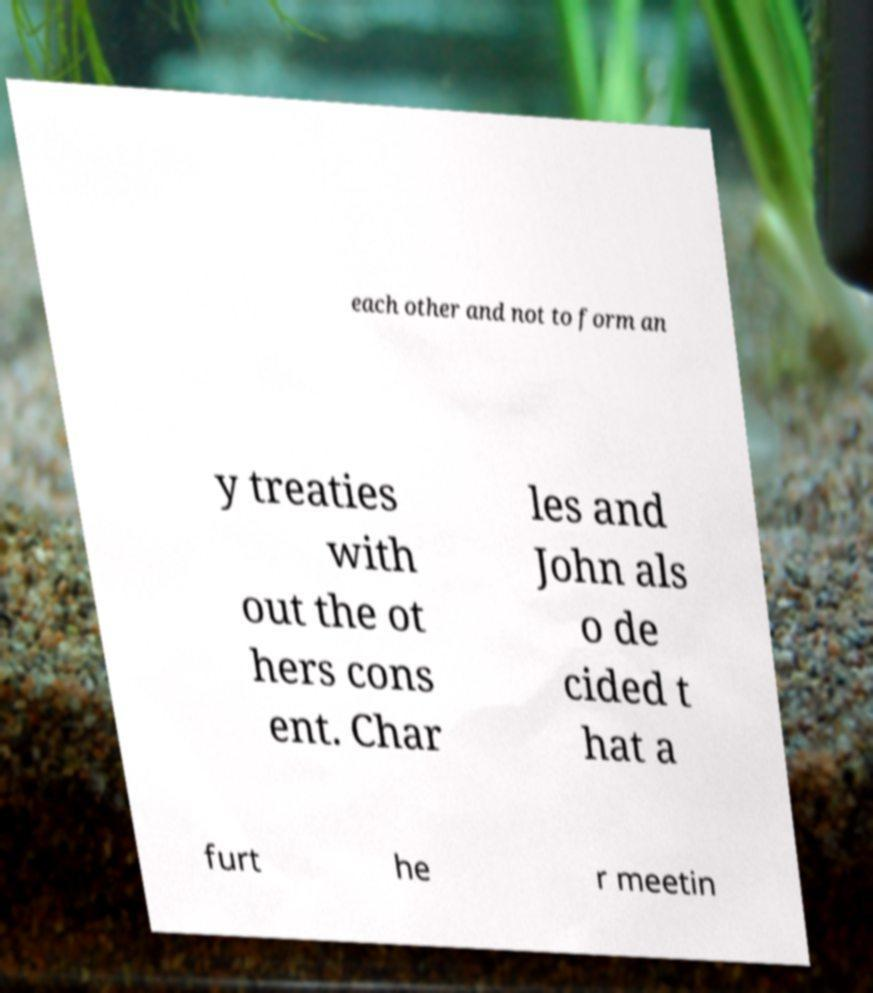I need the written content from this picture converted into text. Can you do that? each other and not to form an y treaties with out the ot hers cons ent. Char les and John als o de cided t hat a furt he r meetin 